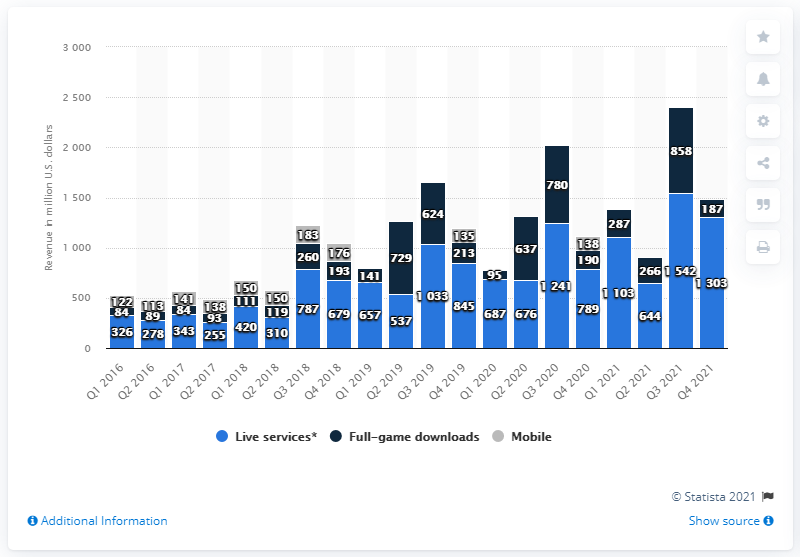Give some essential details in this illustration. Electronic Arts generated 1303 million U.S. dollars in net bookings in the fourth quarter of 2021. In the fourth quarter of the fiscal year 2021, the net bookings from full game sales in the United States were 187. 